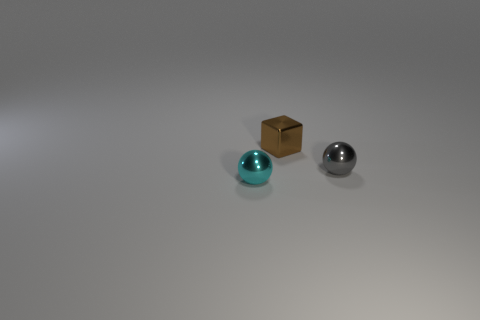The gray thing that is the same material as the small cube is what shape?
Make the answer very short. Sphere. There is a metal sphere that is to the right of the tiny cyan metallic sphere; does it have the same size as the brown block that is behind the small cyan sphere?
Keep it short and to the point. Yes. There is a small metallic thing on the left side of the tiny brown metal block; what shape is it?
Offer a very short reply. Sphere. What is the color of the cube?
Your answer should be compact. Brown. Does the cube have the same size as the metallic ball that is on the right side of the small brown block?
Your answer should be compact. Yes. What number of rubber things are either tiny green cylinders or small cubes?
Ensure brevity in your answer.  0. Is there anything else that has the same material as the cyan sphere?
Provide a succinct answer. Yes. There is a block; does it have the same color as the tiny metallic sphere that is on the right side of the small brown shiny block?
Provide a short and direct response. No. What shape is the tiny cyan metallic object?
Give a very brief answer. Sphere. How big is the metal sphere behind the small metal ball that is in front of the metal ball to the right of the tiny cyan shiny ball?
Offer a terse response. Small. 